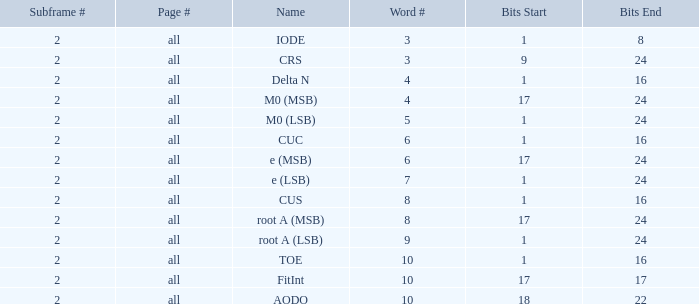What is the page count and word count greater than 5 with Bits of 18–22? All. 